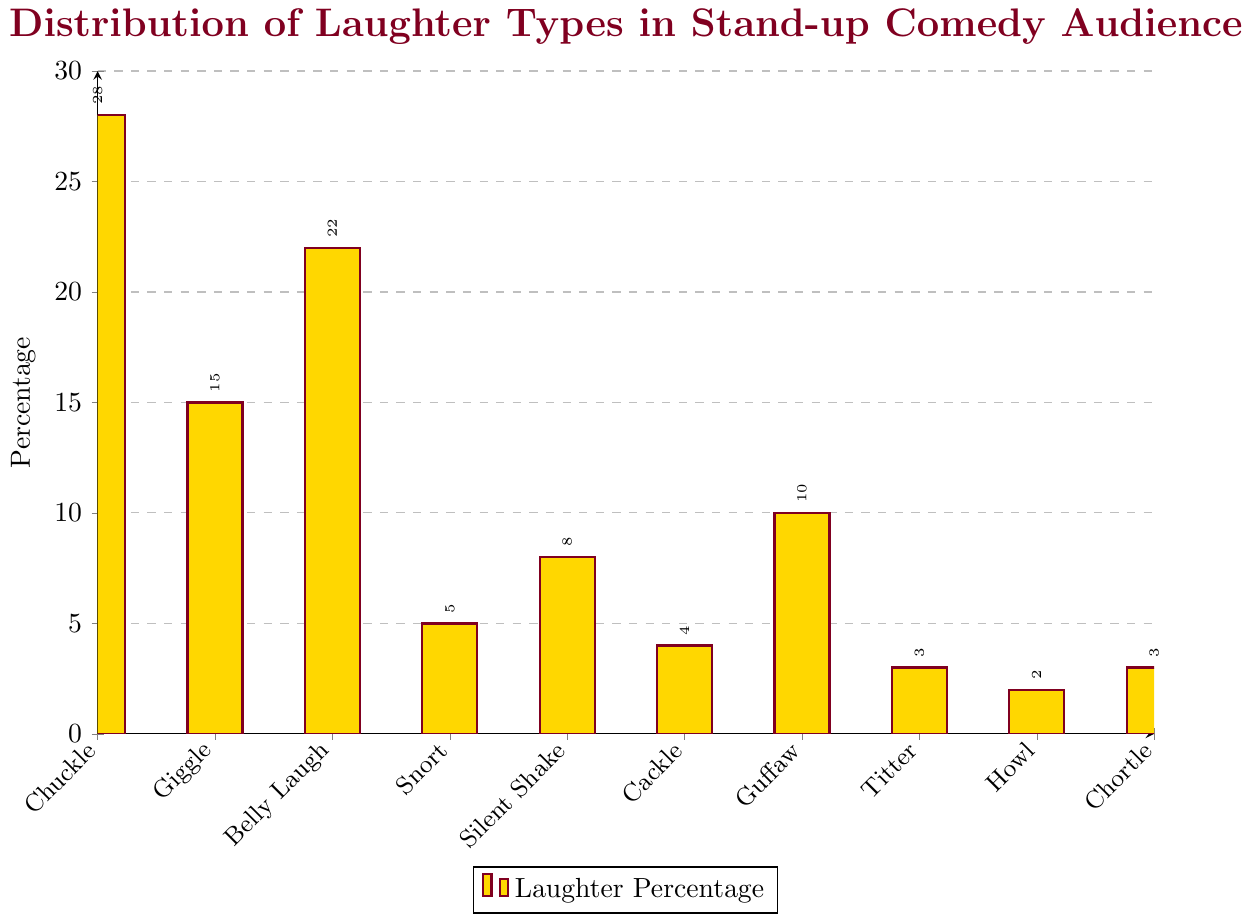What's the most common type of laughter in a stand-up comedy audience? The bar chart shows the percentage of different laughter types, with "chuckle" having the tallest bar, indicating it is the most common.
Answer: Chuckle What's the least common type of laughter shown in the chart? The shortest bar in the chart corresponds to "Howl," indicating it is the least common laughter type.
Answer: Howl How much more common are chuckles compared to giggles? The percentage for chuckles is 28%, and for giggles, it is 15%. The difference is 28% - 15% = 13%.
Answer: 13% What are the combined percentages of belly laughs and guffaws? The percentage for belly laughs is 22%, and for guffaws, it is 10%. The combined total is 22% + 10% = 32%.
Answer: 32% Are belly laughs more common than giggles? By how much? The bar for belly laughs is taller than for giggles. Belly laughs are at 22%, giggles at 15%. The difference is 22% - 15% = 7%.
Answer: Yes, by 7% Which laughter types have a percentage between 5% and 10%? Looking at the bars, types with percentages in this range are Snort (5%), Silent Shake (8%), and Guffaw (10%).
Answer: Snort, Silent Shake, Guffaw What is the average percentage of Titter, Howl, and Chortle? Summing the percentages for Titter (3%), Howl (2%), and Chortle (3%) gives 3% + 2% + 3% = 8%. Dividing by 3, the average is 8% / 3 ≈ 2.67%.
Answer: ~2.67% Is the percentage of Cackles higher or lower than the percentage of Snorts? The bar for Cackle is lower than that for Snort. Cackle is at 4%, while Snort is at 5%.
Answer: Lower Which laughter type shows a smaller percentage, Guffaw or Snort? The Guffaw bar is shorter than the Snort bar. Guffaw is at 10%, Snort is at 5%.
Answer: Snort What's the total percentage of laughter types less than 10%? Summing percentages for Snort (5%), Silent Shake (8%), Cackle (4%), Titter (3%), Howl (2%), and Chortle (3%) gives 5% + 8% + 4% + 3% + 2% + 3% = 25%.
Answer: 25% 